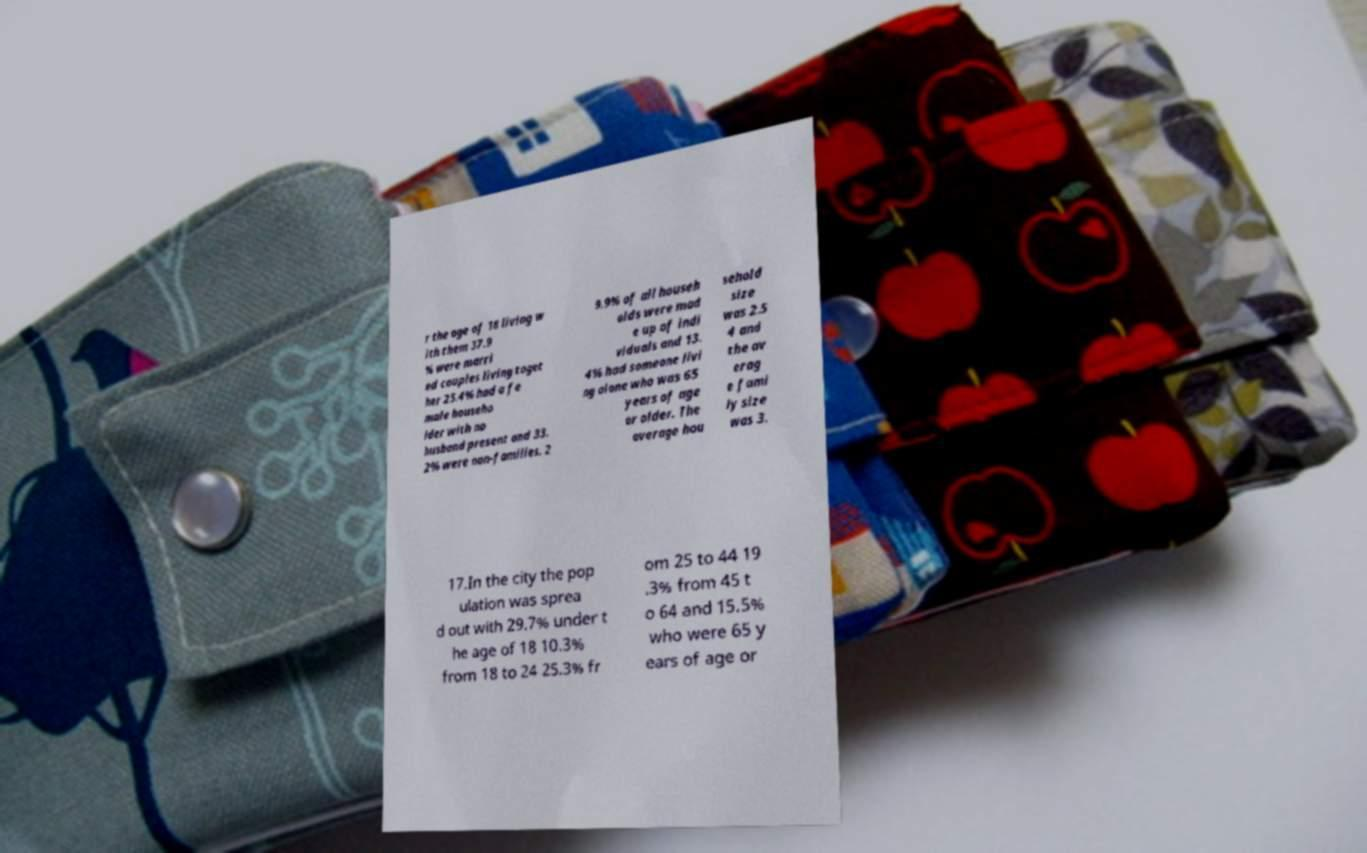For documentation purposes, I need the text within this image transcribed. Could you provide that? r the age of 18 living w ith them 37.9 % were marri ed couples living toget her 25.4% had a fe male househo lder with no husband present and 33. 2% were non-families. 2 9.9% of all househ olds were mad e up of indi viduals and 13. 4% had someone livi ng alone who was 65 years of age or older. The average hou sehold size was 2.5 4 and the av erag e fami ly size was 3. 17.In the city the pop ulation was sprea d out with 29.7% under t he age of 18 10.3% from 18 to 24 25.3% fr om 25 to 44 19 .3% from 45 t o 64 and 15.5% who were 65 y ears of age or 